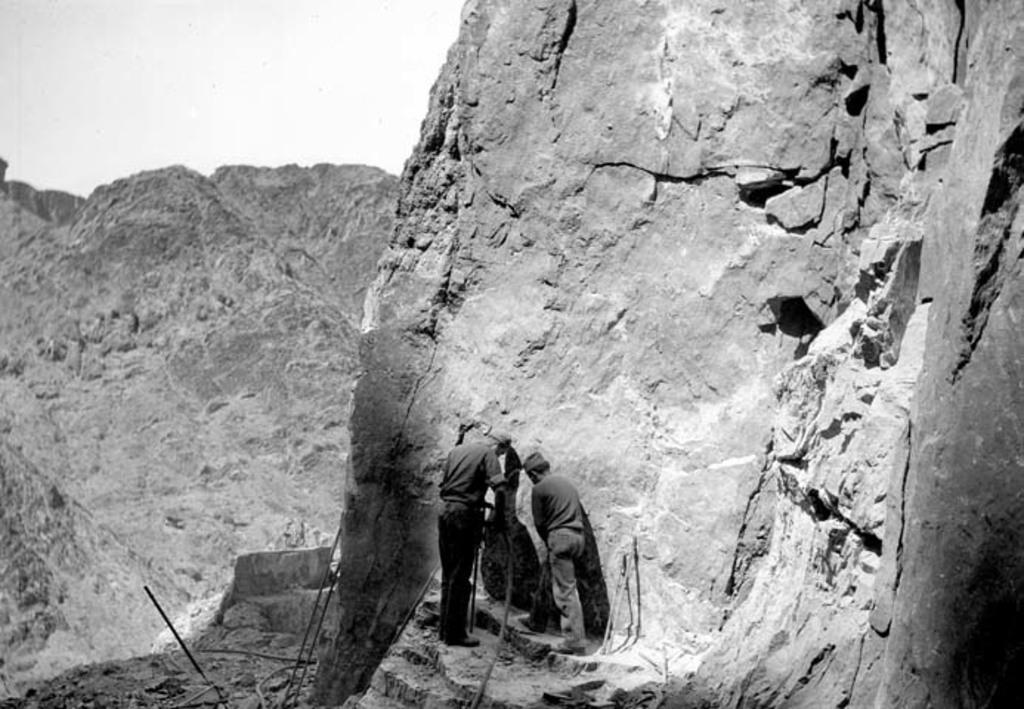How many people are present in the image? There are two persons standing in the image. What can be seen in the background of the image? There are rocks in the background of the image. What is the color scheme of the image? The image is in black and white. Who is the owner of the yard in the image? There is no indication of a yard or an owner in the image. 